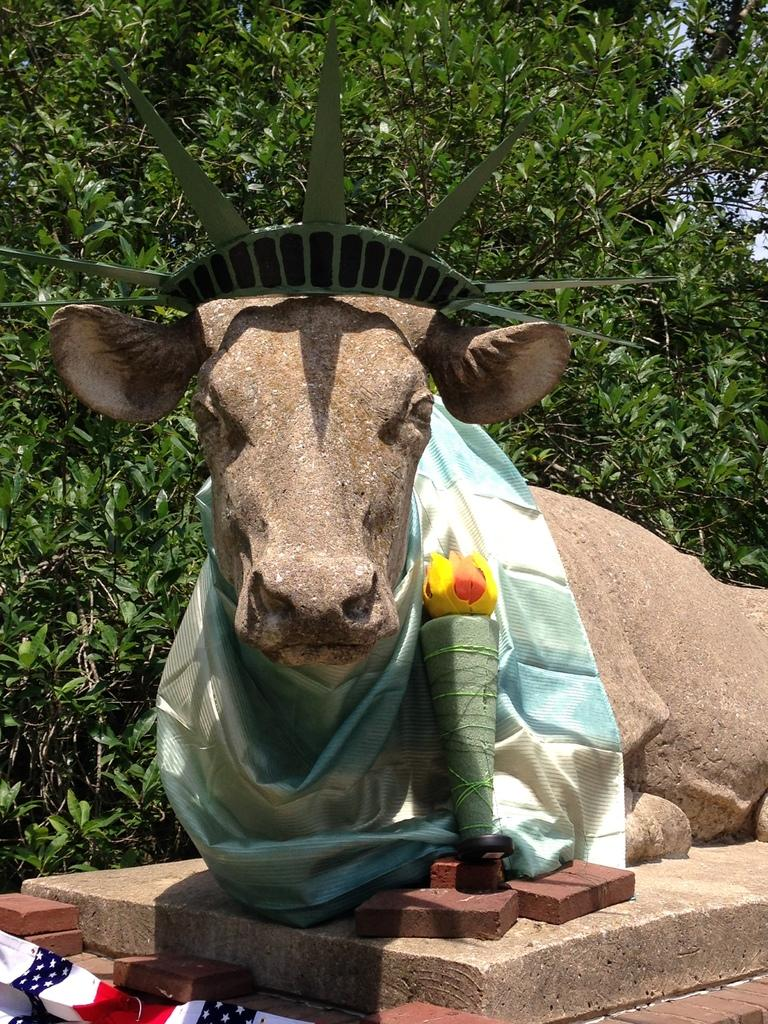What is the main subject in the image? There is a statue in the image. Is there anything associated with the statue? Yes, there is a cloth associated with the statue. What else can be seen near the statue? There are objects present near the statue. What type of vegetation is visible in the background of the image? The background of the image includes green leaves. How many mice are hiding under the fold of the cloth in the image? There are no mice present in the image, and therefore no mice can be found hiding under the cloth. 